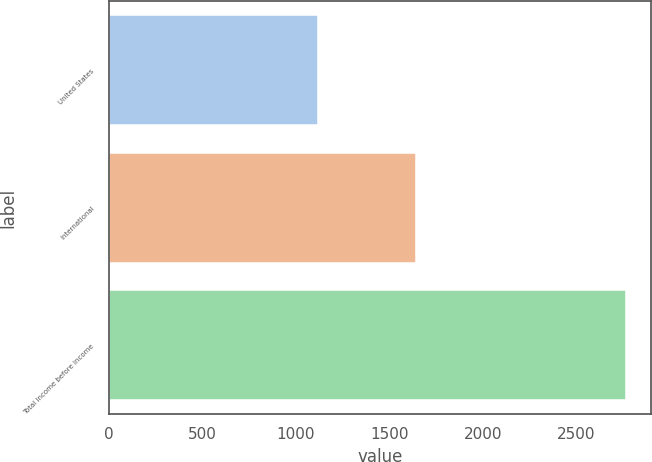<chart> <loc_0><loc_0><loc_500><loc_500><bar_chart><fcel>United States<fcel>International<fcel>Total Income before income<nl><fcel>1118<fcel>1645<fcel>2763<nl></chart> 